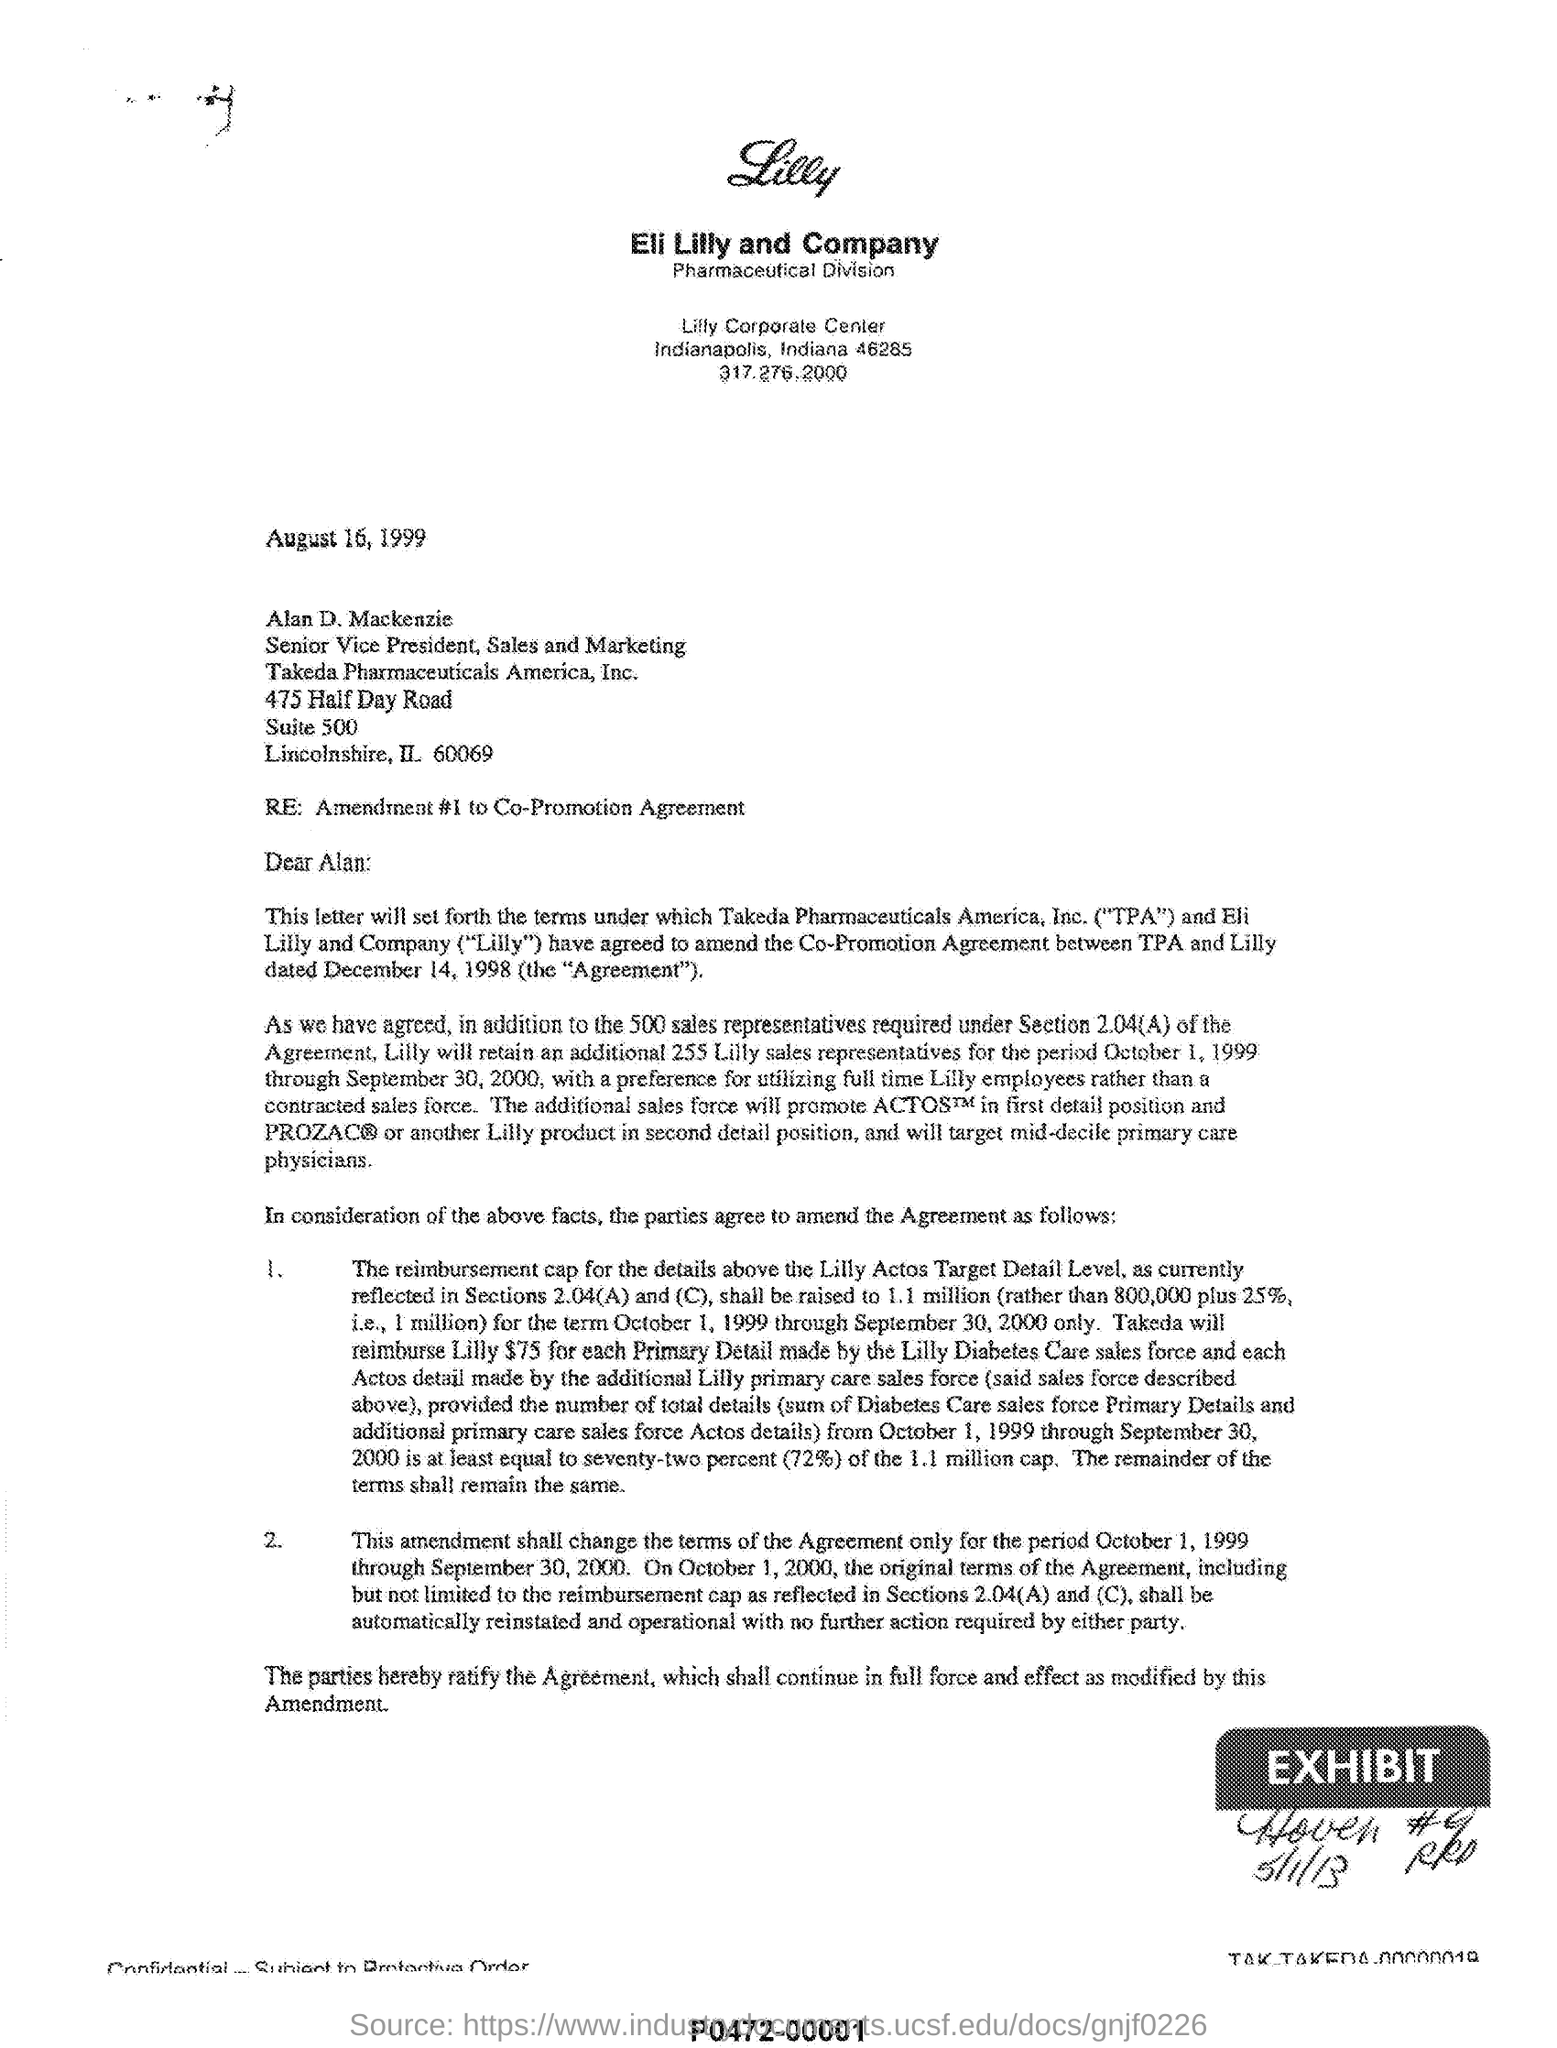List a handful of essential elements in this visual. It has been agreed by Takeda Pharmaceuticals America, Inc. ("TPA") and Eli Lilly and Company ("Lilly") to amend the Co-Promotion Agreement. This letter is addressed to Alan. The date mentioned is August 16, 1999. The acronym 'TPA' stands for 'Takeda Pharmaceuticals America Inc.' which is a pharmaceutical company that specializes in developing and manufacturing a wide range of innovative and high-quality medicines and vaccines for various medical conditions. 